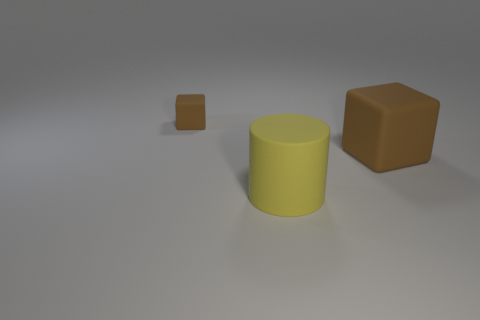Can you describe the objects present in the image and their positions relative to each other? Certainly! In the image, there are three objects on a grey surface. From the foreground to the background, there's a small matte brown cube, a larger yellow matte cylinder in the middle, and a large matte brown cube farther back. The small cube is in front of the yellow cylinder, while the large cube is behind the cylinder, slightly to its right. 